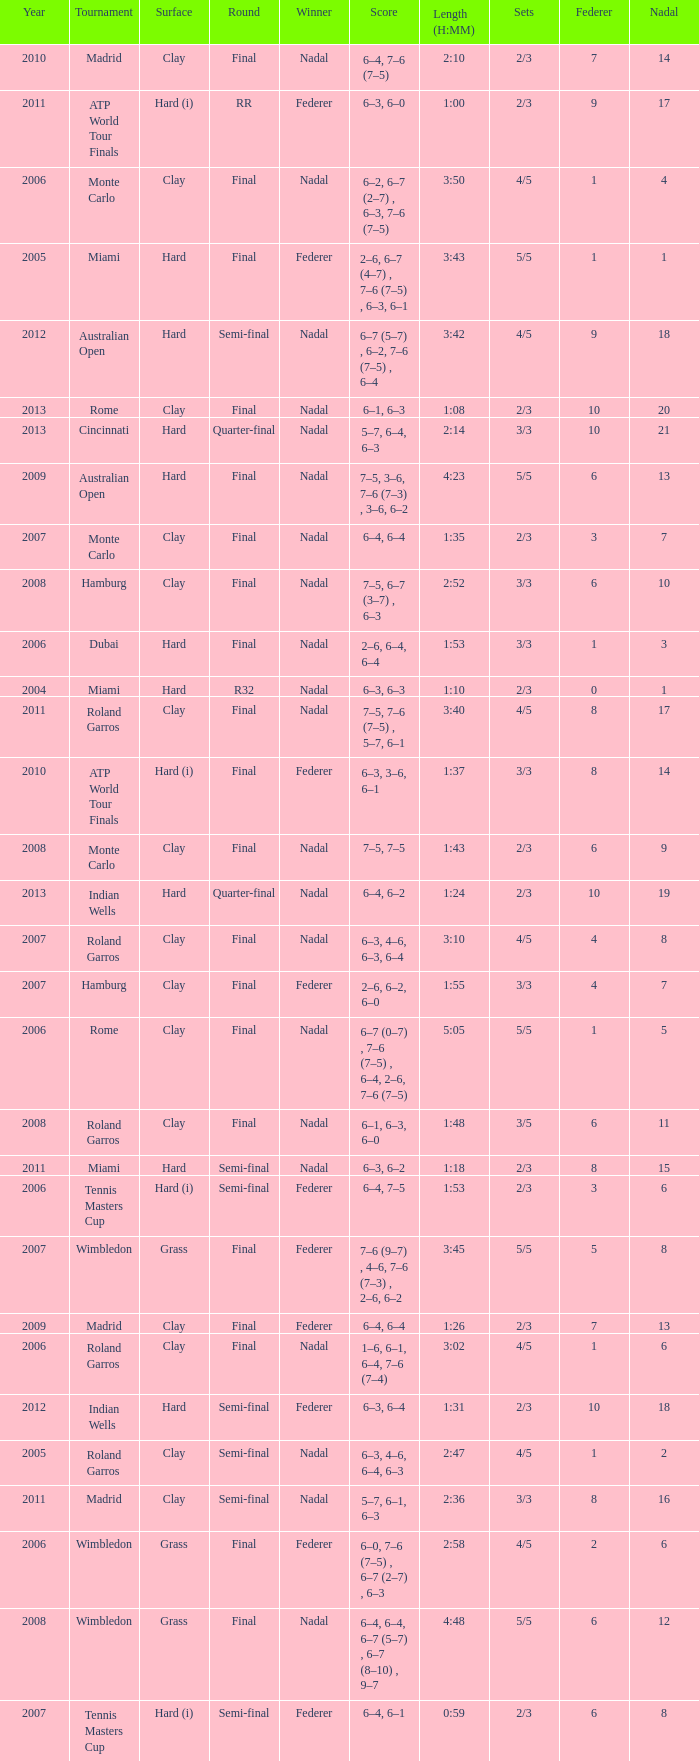What were the sets when Federer had 6 and a nadal of 13? 5/5. Can you parse all the data within this table? {'header': ['Year', 'Tournament', 'Surface', 'Round', 'Winner', 'Score', 'Length (H:MM)', 'Sets', 'Federer', 'Nadal'], 'rows': [['2010', 'Madrid', 'Clay', 'Final', 'Nadal', '6–4, 7–6 (7–5)', '2:10', '2/3', '7', '14'], ['2011', 'ATP World Tour Finals', 'Hard (i)', 'RR', 'Federer', '6–3, 6–0', '1:00', '2/3', '9', '17'], ['2006', 'Monte Carlo', 'Clay', 'Final', 'Nadal', '6–2, 6–7 (2–7) , 6–3, 7–6 (7–5)', '3:50', '4/5', '1', '4'], ['2005', 'Miami', 'Hard', 'Final', 'Federer', '2–6, 6–7 (4–7) , 7–6 (7–5) , 6–3, 6–1', '3:43', '5/5', '1', '1'], ['2012', 'Australian Open', 'Hard', 'Semi-final', 'Nadal', '6–7 (5–7) , 6–2, 7–6 (7–5) , 6–4', '3:42', '4/5', '9', '18'], ['2013', 'Rome', 'Clay', 'Final', 'Nadal', '6–1, 6–3', '1:08', '2/3', '10', '20'], ['2013', 'Cincinnati', 'Hard', 'Quarter-final', 'Nadal', '5–7, 6–4, 6–3', '2:14', '3/3', '10', '21'], ['2009', 'Australian Open', 'Hard', 'Final', 'Nadal', '7–5, 3–6, 7–6 (7–3) , 3–6, 6–2', '4:23', '5/5', '6', '13'], ['2007', 'Monte Carlo', 'Clay', 'Final', 'Nadal', '6–4, 6–4', '1:35', '2/3', '3', '7'], ['2008', 'Hamburg', 'Clay', 'Final', 'Nadal', '7–5, 6–7 (3–7) , 6–3', '2:52', '3/3', '6', '10'], ['2006', 'Dubai', 'Hard', 'Final', 'Nadal', '2–6, 6–4, 6–4', '1:53', '3/3', '1', '3'], ['2004', 'Miami', 'Hard', 'R32', 'Nadal', '6–3, 6–3', '1:10', '2/3', '0', '1'], ['2011', 'Roland Garros', 'Clay', 'Final', 'Nadal', '7–5, 7–6 (7–5) , 5–7, 6–1', '3:40', '4/5', '8', '17'], ['2010', 'ATP World Tour Finals', 'Hard (i)', 'Final', 'Federer', '6–3, 3–6, 6–1', '1:37', '3/3', '8', '14'], ['2008', 'Monte Carlo', 'Clay', 'Final', 'Nadal', '7–5, 7–5', '1:43', '2/3', '6', '9'], ['2013', 'Indian Wells', 'Hard', 'Quarter-final', 'Nadal', '6–4, 6–2', '1:24', '2/3', '10', '19'], ['2007', 'Roland Garros', 'Clay', 'Final', 'Nadal', '6–3, 4–6, 6–3, 6–4', '3:10', '4/5', '4', '8'], ['2007', 'Hamburg', 'Clay', 'Final', 'Federer', '2–6, 6–2, 6–0', '1:55', '3/3', '4', '7'], ['2006', 'Rome', 'Clay', 'Final', 'Nadal', '6–7 (0–7) , 7–6 (7–5) , 6–4, 2–6, 7–6 (7–5)', '5:05', '5/5', '1', '5'], ['2008', 'Roland Garros', 'Clay', 'Final', 'Nadal', '6–1, 6–3, 6–0', '1:48', '3/5', '6', '11'], ['2011', 'Miami', 'Hard', 'Semi-final', 'Nadal', '6–3, 6–2', '1:18', '2/3', '8', '15'], ['2006', 'Tennis Masters Cup', 'Hard (i)', 'Semi-final', 'Federer', '6–4, 7–5', '1:53', '2/3', '3', '6'], ['2007', 'Wimbledon', 'Grass', 'Final', 'Federer', '7–6 (9–7) , 4–6, 7–6 (7–3) , 2–6, 6–2', '3:45', '5/5', '5', '8'], ['2009', 'Madrid', 'Clay', 'Final', 'Federer', '6–4, 6–4', '1:26', '2/3', '7', '13'], ['2006', 'Roland Garros', 'Clay', 'Final', 'Nadal', '1–6, 6–1, 6–4, 7–6 (7–4)', '3:02', '4/5', '1', '6'], ['2012', 'Indian Wells', 'Hard', 'Semi-final', 'Federer', '6–3, 6–4', '1:31', '2/3', '10', '18'], ['2005', 'Roland Garros', 'Clay', 'Semi-final', 'Nadal', '6–3, 4–6, 6–4, 6–3', '2:47', '4/5', '1', '2'], ['2011', 'Madrid', 'Clay', 'Semi-final', 'Nadal', '5–7, 6–1, 6–3', '2:36', '3/3', '8', '16'], ['2006', 'Wimbledon', 'Grass', 'Final', 'Federer', '6–0, 7–6 (7–5) , 6–7 (2–7) , 6–3', '2:58', '4/5', '2', '6'], ['2008', 'Wimbledon', 'Grass', 'Final', 'Nadal', '6–4, 6–4, 6–7 (5–7) , 6–7 (8–10) , 9–7', '4:48', '5/5', '6', '12'], ['2007', 'Tennis Masters Cup', 'Hard (i)', 'Semi-final', 'Federer', '6–4, 6–1', '0:59', '2/3', '6', '8']]} 